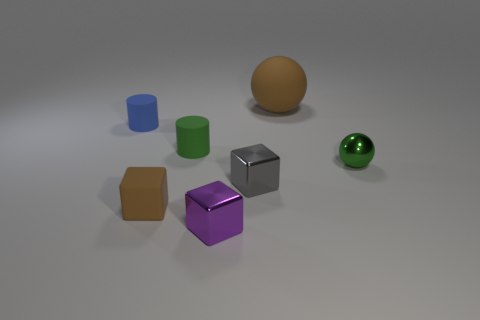Which objects in the image have a metallic texture? The small silver cube and the golden sphere appear to have a metallic texture, reflecting light and exhibiting a shiny surface. 